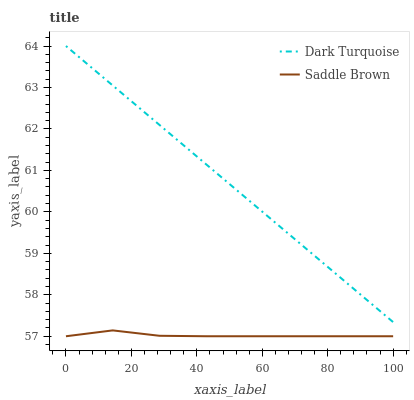Does Saddle Brown have the minimum area under the curve?
Answer yes or no. Yes. Does Dark Turquoise have the maximum area under the curve?
Answer yes or no. Yes. Does Saddle Brown have the maximum area under the curve?
Answer yes or no. No. Is Dark Turquoise the smoothest?
Answer yes or no. Yes. Is Saddle Brown the roughest?
Answer yes or no. Yes. Is Saddle Brown the smoothest?
Answer yes or no. No. Does Saddle Brown have the lowest value?
Answer yes or no. Yes. Does Dark Turquoise have the highest value?
Answer yes or no. Yes. Does Saddle Brown have the highest value?
Answer yes or no. No. Is Saddle Brown less than Dark Turquoise?
Answer yes or no. Yes. Is Dark Turquoise greater than Saddle Brown?
Answer yes or no. Yes. Does Saddle Brown intersect Dark Turquoise?
Answer yes or no. No. 